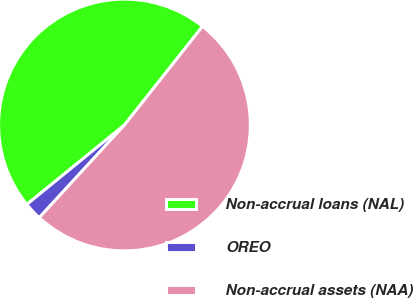Convert chart. <chart><loc_0><loc_0><loc_500><loc_500><pie_chart><fcel>Non-accrual loans (NAL)<fcel>OREO<fcel>Non-accrual assets (NAA)<nl><fcel>46.53%<fcel>2.29%<fcel>51.18%<nl></chart> 